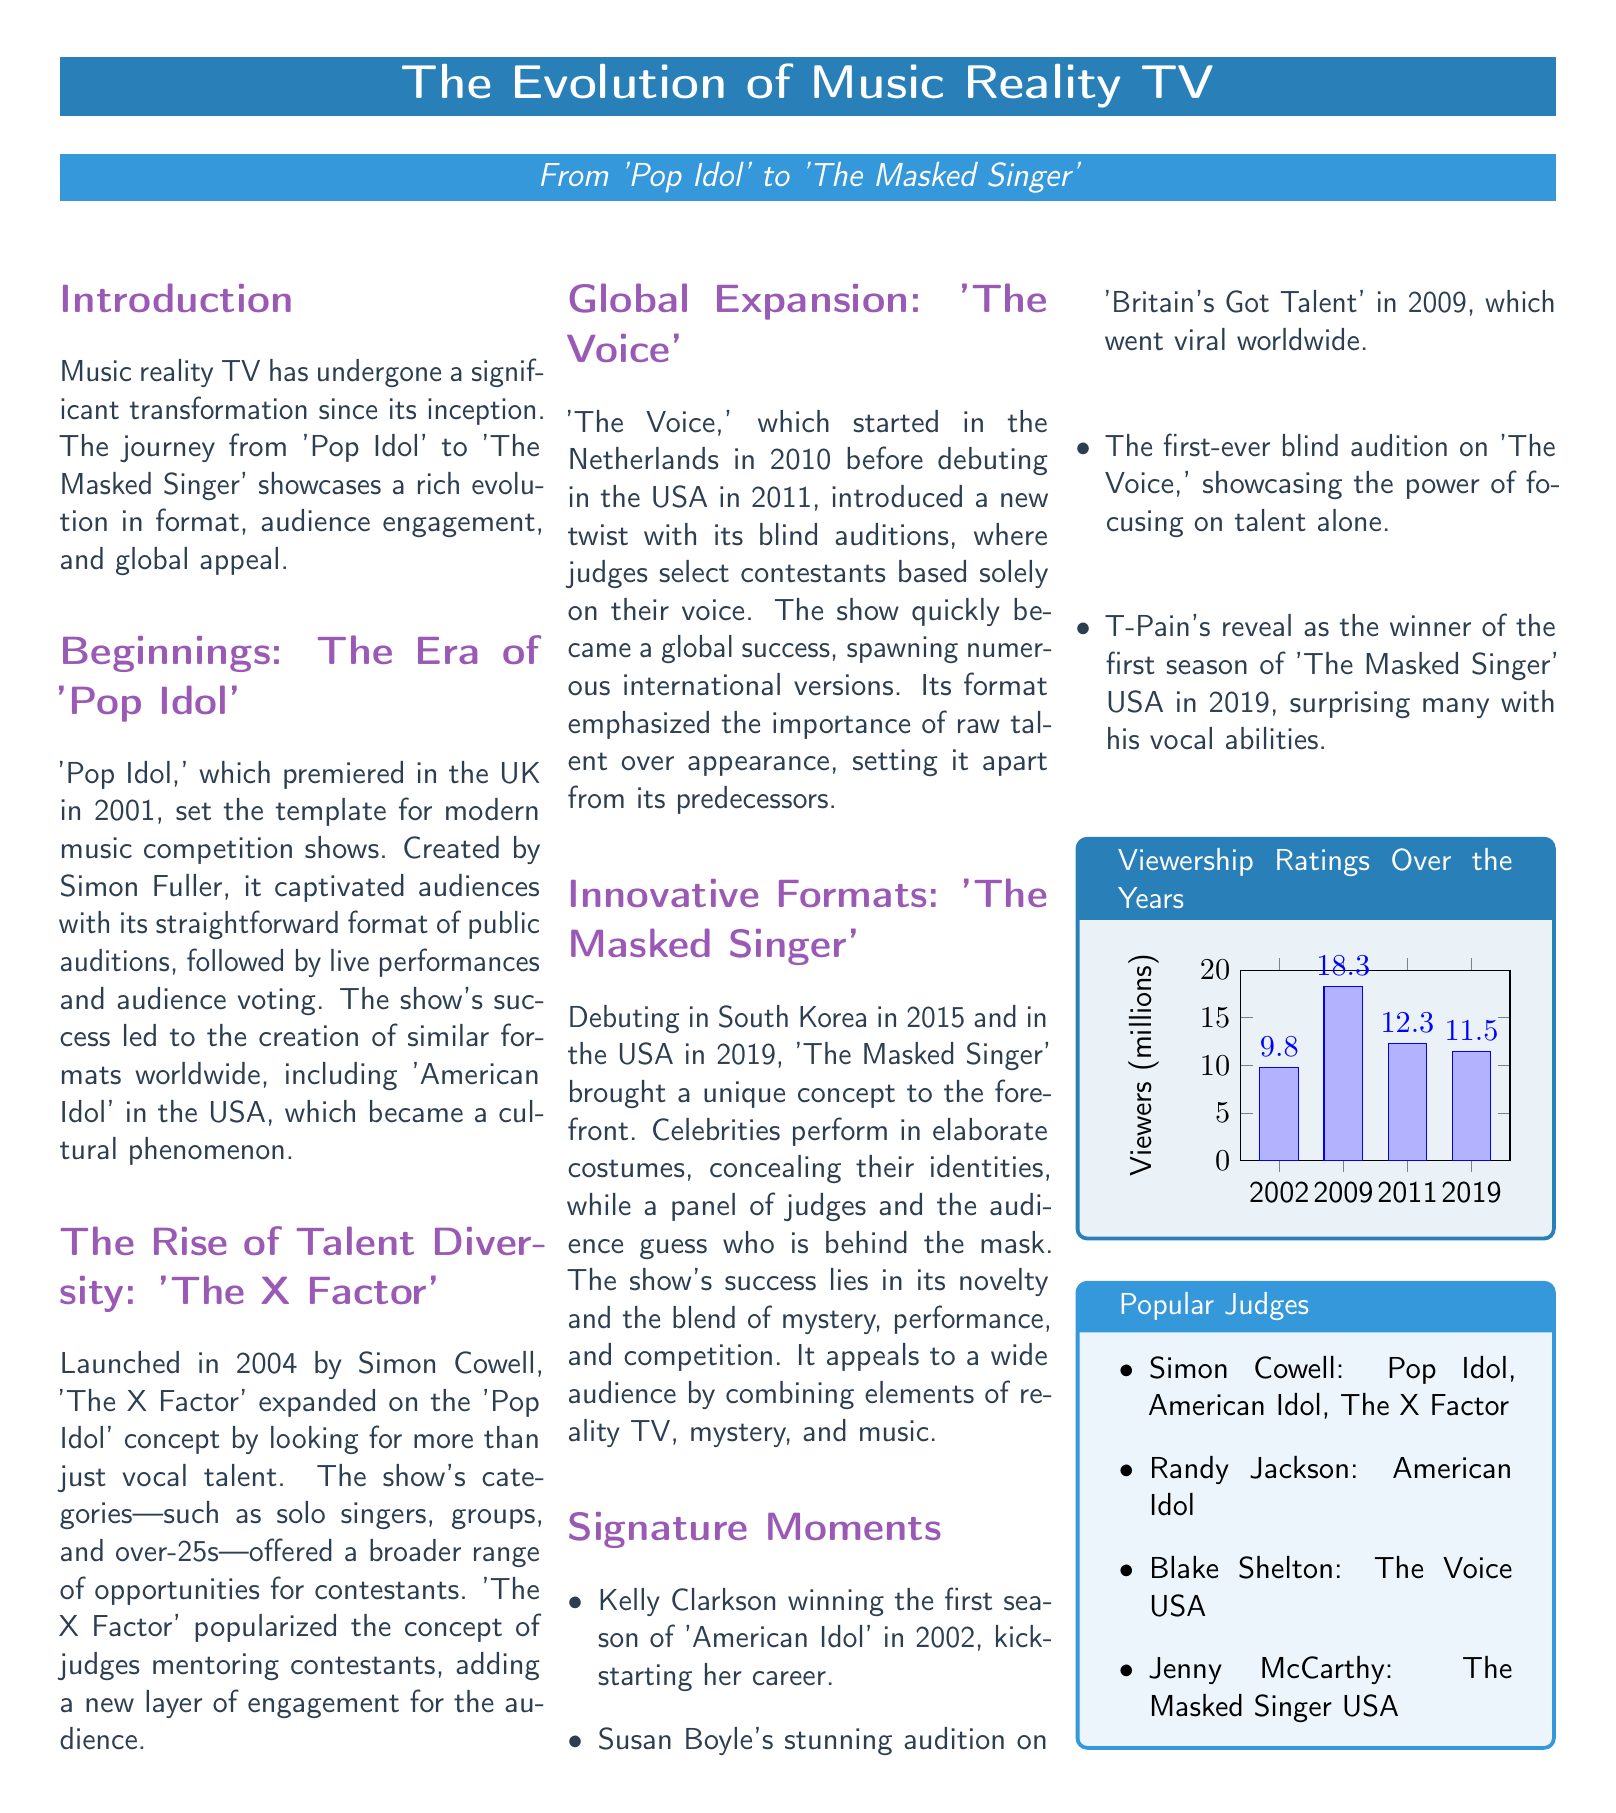What show premiered in 2001? The document states that 'Pop Idol' premiered in the UK in 2001, serving as the template for modern music competition shows.
Answer: 'Pop Idol' Who created 'Pop Idol'? According to the document, 'Pop Idol' was created by Simon Fuller.
Answer: Simon Fuller What year did 'The X Factor' launch? The document mentions that 'The X Factor' was launched in 2004 by Simon Cowell.
Answer: 2004 Which show introduced blind auditions? The document highlights that 'The Voice' introduced a new twist with its blind auditions that focused solely on the contestants' voices.
Answer: 'The Voice' What was the viewership rating in 2009? The viewership ratings in the document indicate that the viewers in millions for 2009 were 18.3 million.
Answer: 18.3 Name one popular judge mentioned. The document lists various popular judges, including Simon Cowell, who is associated with multiple shows like 'Pop Idol' and 'American Idol'.
Answer: Simon Cowell What significant event occurred in 2002? The document notes that Kelly Clarkson won the first season of 'American Idol' in 2002, which kickstarted her career.
Answer: Kelly Clarkson's win Which show debuted in South Korea in 2015? The document states that 'The Masked Singer' debuted in South Korea in 2015 before coming to the USA.
Answer: 'The Masked Singer' How many shows' viewership ratings are presented in the chart? The chart in the document represents viewership ratings for four specific years corresponding to different shows.
Answer: Four 